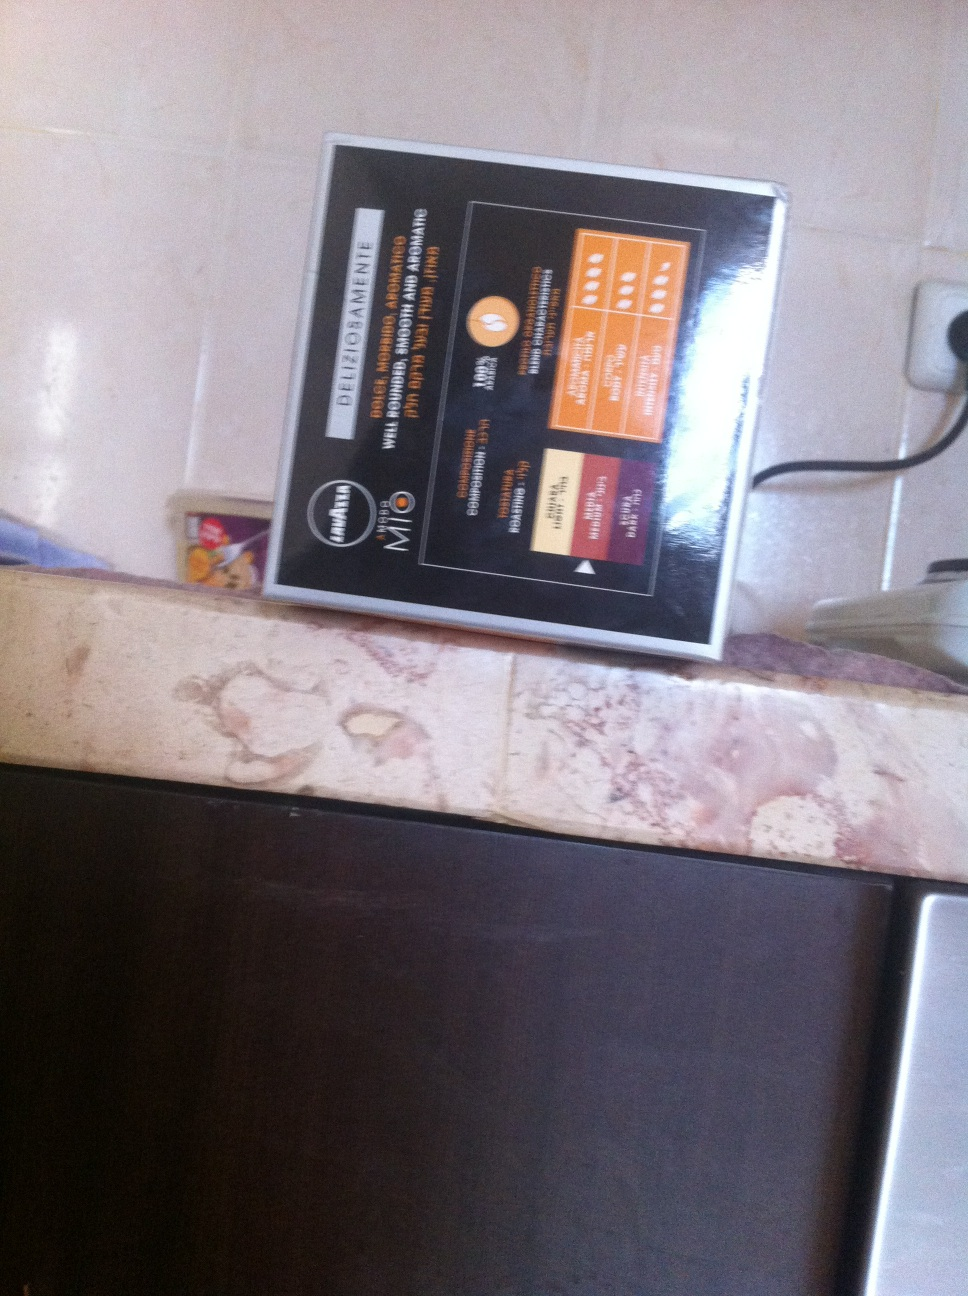Can you tell me more about the sections listed on this dietary management guide? Certainly! The guide includes sections on basic tips for healthy eating, a special section on low carb diets, another part discusses high fiber diets, and there's information on maintaining sufficient protein intake. Additionally, it highlights the importance of low salt and sugar intake. 